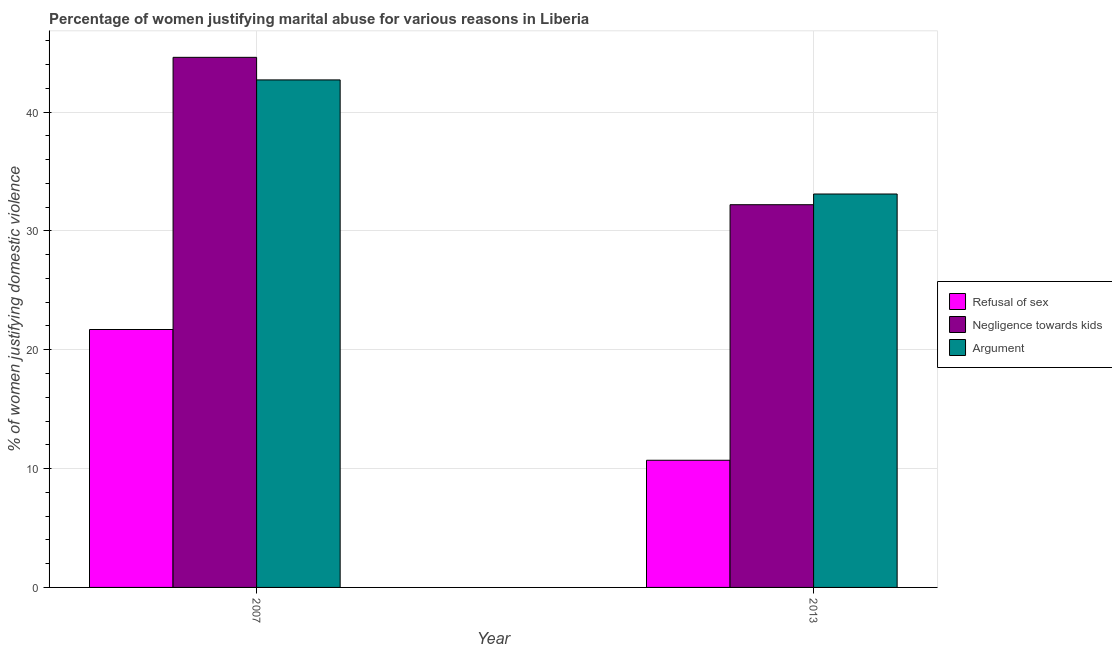How many different coloured bars are there?
Provide a short and direct response. 3. How many groups of bars are there?
Make the answer very short. 2. Are the number of bars on each tick of the X-axis equal?
Your response must be concise. Yes. In how many cases, is the number of bars for a given year not equal to the number of legend labels?
Offer a terse response. 0. What is the percentage of women justifying domestic violence due to arguments in 2007?
Your answer should be very brief. 42.7. Across all years, what is the maximum percentage of women justifying domestic violence due to refusal of sex?
Provide a short and direct response. 21.7. Across all years, what is the minimum percentage of women justifying domestic violence due to arguments?
Keep it short and to the point. 33.1. In which year was the percentage of women justifying domestic violence due to refusal of sex maximum?
Provide a succinct answer. 2007. In which year was the percentage of women justifying domestic violence due to negligence towards kids minimum?
Offer a terse response. 2013. What is the total percentage of women justifying domestic violence due to refusal of sex in the graph?
Give a very brief answer. 32.4. What is the difference between the percentage of women justifying domestic violence due to negligence towards kids in 2007 and the percentage of women justifying domestic violence due to refusal of sex in 2013?
Ensure brevity in your answer.  12.4. What is the average percentage of women justifying domestic violence due to negligence towards kids per year?
Provide a short and direct response. 38.4. In the year 2007, what is the difference between the percentage of women justifying domestic violence due to refusal of sex and percentage of women justifying domestic violence due to negligence towards kids?
Give a very brief answer. 0. What is the ratio of the percentage of women justifying domestic violence due to arguments in 2007 to that in 2013?
Your answer should be compact. 1.29. What does the 3rd bar from the left in 2013 represents?
Your answer should be compact. Argument. What does the 3rd bar from the right in 2013 represents?
Provide a short and direct response. Refusal of sex. Does the graph contain grids?
Ensure brevity in your answer.  Yes. Where does the legend appear in the graph?
Your answer should be very brief. Center right. How are the legend labels stacked?
Offer a very short reply. Vertical. What is the title of the graph?
Keep it short and to the point. Percentage of women justifying marital abuse for various reasons in Liberia. Does "Natural Gas" appear as one of the legend labels in the graph?
Make the answer very short. No. What is the label or title of the X-axis?
Provide a short and direct response. Year. What is the label or title of the Y-axis?
Your answer should be very brief. % of women justifying domestic violence. What is the % of women justifying domestic violence of Refusal of sex in 2007?
Provide a short and direct response. 21.7. What is the % of women justifying domestic violence in Negligence towards kids in 2007?
Your response must be concise. 44.6. What is the % of women justifying domestic violence in Argument in 2007?
Ensure brevity in your answer.  42.7. What is the % of women justifying domestic violence in Negligence towards kids in 2013?
Provide a succinct answer. 32.2. What is the % of women justifying domestic violence of Argument in 2013?
Ensure brevity in your answer.  33.1. Across all years, what is the maximum % of women justifying domestic violence of Refusal of sex?
Your answer should be compact. 21.7. Across all years, what is the maximum % of women justifying domestic violence in Negligence towards kids?
Ensure brevity in your answer.  44.6. Across all years, what is the maximum % of women justifying domestic violence in Argument?
Make the answer very short. 42.7. Across all years, what is the minimum % of women justifying domestic violence in Negligence towards kids?
Provide a succinct answer. 32.2. Across all years, what is the minimum % of women justifying domestic violence in Argument?
Your response must be concise. 33.1. What is the total % of women justifying domestic violence in Refusal of sex in the graph?
Provide a short and direct response. 32.4. What is the total % of women justifying domestic violence in Negligence towards kids in the graph?
Your response must be concise. 76.8. What is the total % of women justifying domestic violence of Argument in the graph?
Ensure brevity in your answer.  75.8. What is the difference between the % of women justifying domestic violence of Refusal of sex in 2007 and that in 2013?
Make the answer very short. 11. What is the difference between the % of women justifying domestic violence in Negligence towards kids in 2007 and that in 2013?
Your response must be concise. 12.4. What is the difference between the % of women justifying domestic violence of Refusal of sex in 2007 and the % of women justifying domestic violence of Argument in 2013?
Keep it short and to the point. -11.4. What is the average % of women justifying domestic violence in Refusal of sex per year?
Provide a succinct answer. 16.2. What is the average % of women justifying domestic violence of Negligence towards kids per year?
Provide a short and direct response. 38.4. What is the average % of women justifying domestic violence in Argument per year?
Offer a terse response. 37.9. In the year 2007, what is the difference between the % of women justifying domestic violence in Refusal of sex and % of women justifying domestic violence in Negligence towards kids?
Your response must be concise. -22.9. In the year 2007, what is the difference between the % of women justifying domestic violence of Refusal of sex and % of women justifying domestic violence of Argument?
Keep it short and to the point. -21. In the year 2013, what is the difference between the % of women justifying domestic violence of Refusal of sex and % of women justifying domestic violence of Negligence towards kids?
Give a very brief answer. -21.5. In the year 2013, what is the difference between the % of women justifying domestic violence of Refusal of sex and % of women justifying domestic violence of Argument?
Your response must be concise. -22.4. In the year 2013, what is the difference between the % of women justifying domestic violence in Negligence towards kids and % of women justifying domestic violence in Argument?
Make the answer very short. -0.9. What is the ratio of the % of women justifying domestic violence in Refusal of sex in 2007 to that in 2013?
Your answer should be very brief. 2.03. What is the ratio of the % of women justifying domestic violence in Negligence towards kids in 2007 to that in 2013?
Provide a succinct answer. 1.39. What is the ratio of the % of women justifying domestic violence of Argument in 2007 to that in 2013?
Ensure brevity in your answer.  1.29. What is the difference between the highest and the second highest % of women justifying domestic violence of Negligence towards kids?
Give a very brief answer. 12.4. What is the difference between the highest and the second highest % of women justifying domestic violence of Argument?
Your answer should be compact. 9.6. 